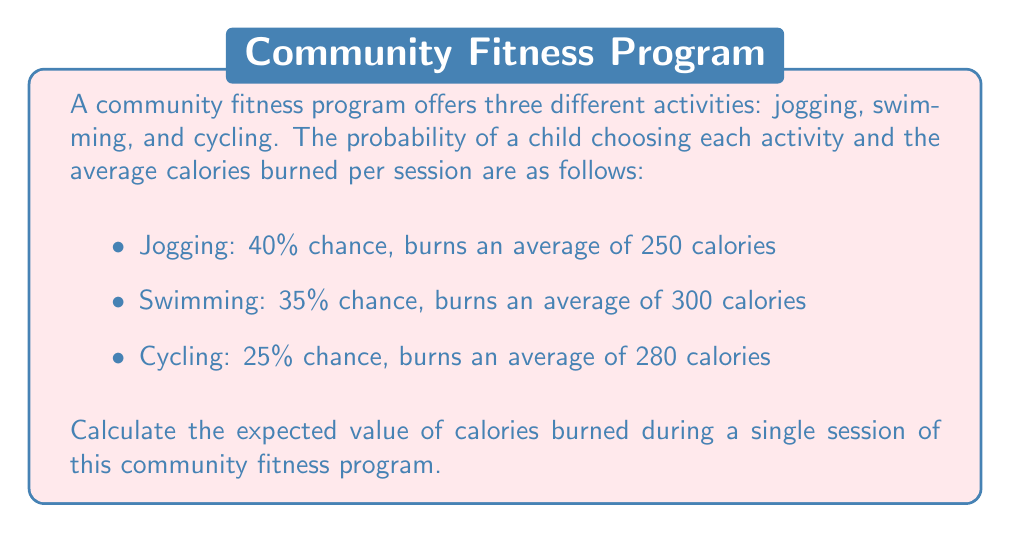Could you help me with this problem? To calculate the expected value of calories burned, we need to follow these steps:

1. Identify the probability and calorie burn for each activity:
   - Jogging: $P(\text{Jogging}) = 0.40$, Calories = 250
   - Swimming: $P(\text{Swimming}) = 0.35$, Calories = 300
   - Cycling: $P(\text{Cycling}) = 0.25$, Calories = 280

2. Calculate the expected value using the formula:
   $$E(\text{Calories}) = \sum_{i=1}^{n} P(X_i) \cdot \text{Calories}_i$$

   Where $X_i$ represents each activity, $P(X_i)$ is the probability of choosing that activity, and $\text{Calories}_i$ is the number of calories burned for that activity.

3. Substitute the values into the formula:
   $$E(\text{Calories}) = (0.40 \cdot 250) + (0.35 \cdot 300) + (0.25 \cdot 280)$$

4. Perform the calculations:
   $$E(\text{Calories}) = 100 + 105 + 70 = 275$$

Therefore, the expected value of calories burned during a single session of this community fitness program is 275 calories.
Answer: 275 calories 